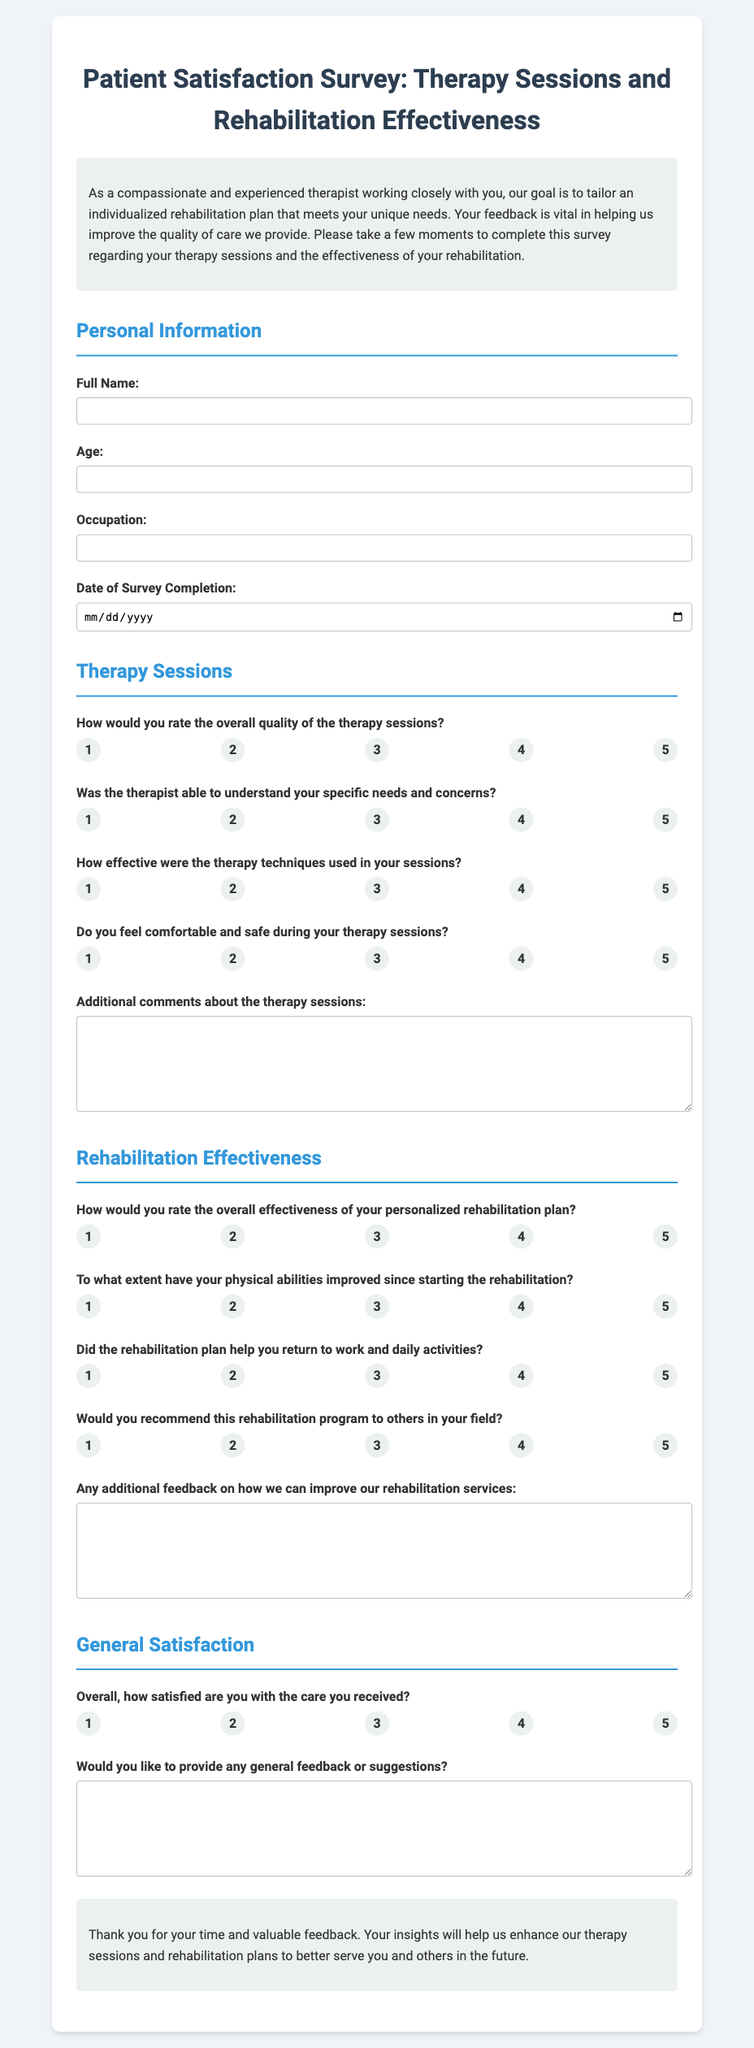What is the title of the document? The title is displayed prominently at the top of the document, indicating the subject matter.
Answer: Patient Satisfaction Survey: Therapy Sessions and Rehabilitation Effectiveness What information is required for personal information? The form specifies four fields that must be filled out; these relate to personal details of the patient.
Answer: Full Name, Age, Occupation, Date of Survey Completion How would you rate the overall quality of the therapy sessions? This is a question in the survey presenting a scale for the respondent to grading their experiences.
Answer: Rating scale from 1 to 5 What is the purpose of the survey as stated in the introduction? The introduction summarizes the main aim of the survey, emphasizing the importance of patient feedback for quality improvement.
Answer: To tailor an individualized rehabilitation plan that meets unique needs To what extent have your physical abilities improved since starting rehabilitation? This question asks for an assessment of physical improvements made during therapy sessions.
Answer: Rating scale from 1 to 5 How is the effectiveness of the personalized rehabilitation plan rated? The form indicates a method for patients to express their satisfaction with their rehabilitation plans.
Answer: Rating scale from 1 to 5 What do patients give feedback on regarding their therapy sessions? At the end of the therapy sessions section, there is a prompt for additional remarks about the sessions.
Answer: Additional comments about the therapy sessions Would you recommend this rehabilitation program to others in your field? This question asks patients to evaluate the likelihood that they would suggest the rehabilitation program to their peers.
Answer: Rating scale from 1 to 5 